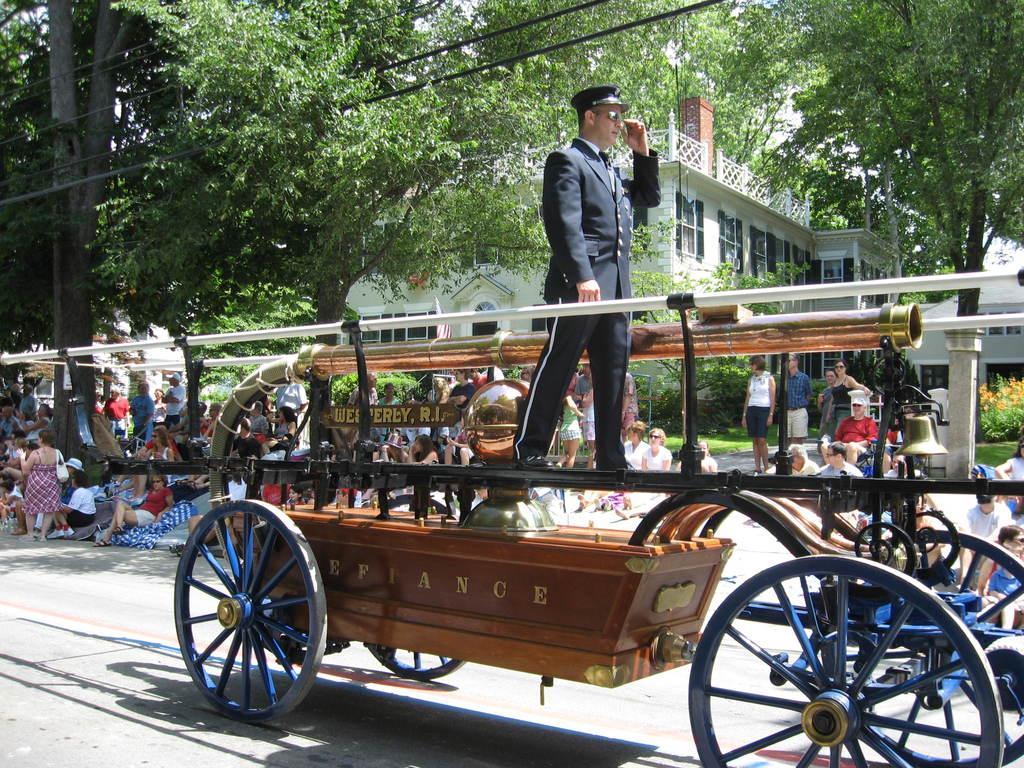In one or two sentences, can you explain what this image depicts? In this picture we can see the man wearing a black suit, standing on the four wheeled chariot. Behind there are some group of people sitting and looking to the rally. Behind we can see some trees and white color building. 